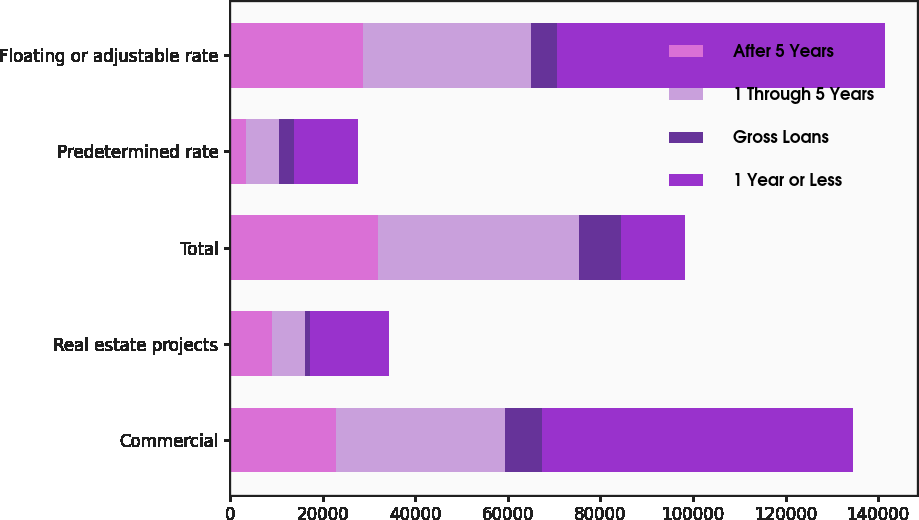<chart> <loc_0><loc_0><loc_500><loc_500><stacked_bar_chart><ecel><fcel>Commercial<fcel>Real estate projects<fcel>Total<fcel>Predetermined rate<fcel>Floating or adjustable rate<nl><fcel>After 5 Years<fcel>22866<fcel>9134<fcel>32000<fcel>3408<fcel>28592<nl><fcel>1 Through 5 Years<fcel>36425<fcel>7048<fcel>43473<fcel>7077<fcel>36396<nl><fcel>Gross Loans<fcel>8028<fcel>994<fcel>9022<fcel>3315<fcel>5707<nl><fcel>1 Year or Less<fcel>67319<fcel>17176<fcel>13800<fcel>13800<fcel>70695<nl></chart> 